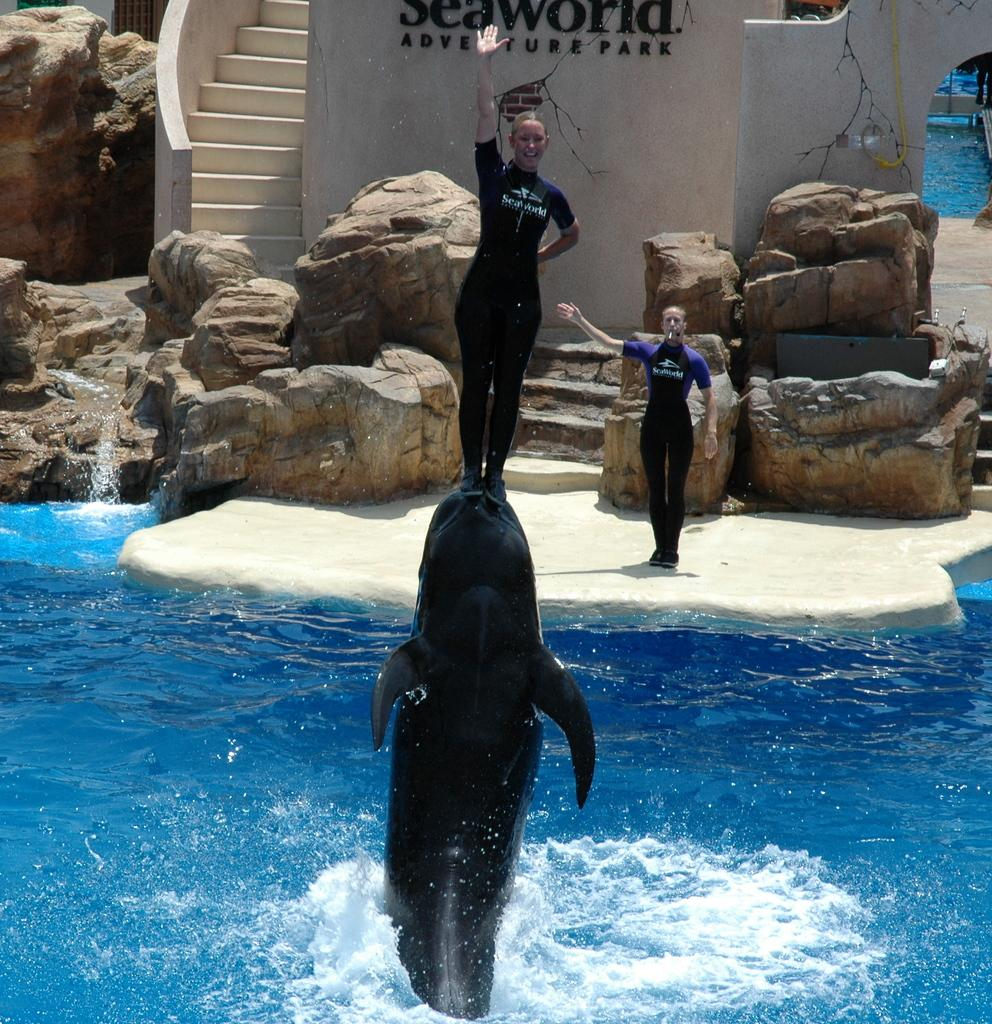How many people are in the image? There are two people in the image. What is the person standing on in the image? The person is standing on a dolphin in the water. What can be seen in the background of the image? There are stones, stairs, and a wall visible in the background. What is written on the wall in the image? Some text is written on the wall in the image. What type of spoon is being used to stir the waves in the image? There is no spoon or stirring activity present in the image. What sound do the bells make in the image? There are no bells present in the image. 